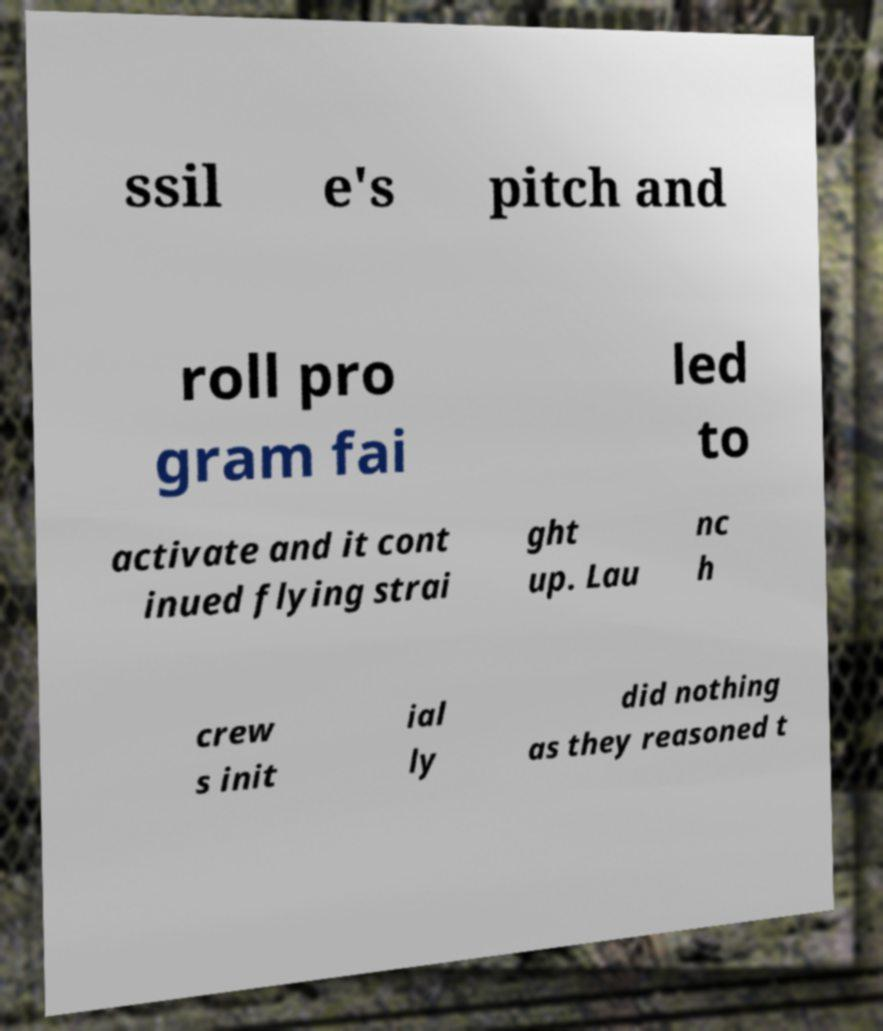Could you extract and type out the text from this image? ssil e's pitch and roll pro gram fai led to activate and it cont inued flying strai ght up. Lau nc h crew s init ial ly did nothing as they reasoned t 